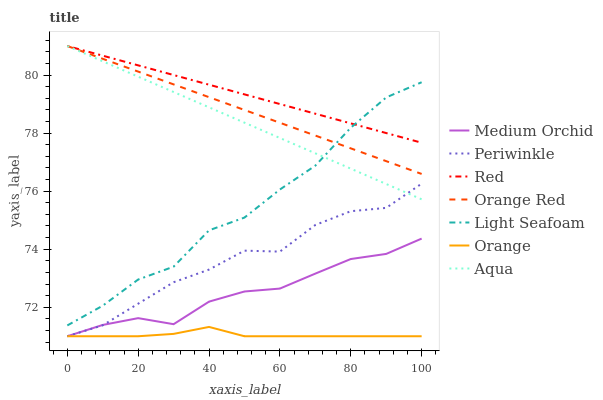Does Orange have the minimum area under the curve?
Answer yes or no. Yes. Does Red have the maximum area under the curve?
Answer yes or no. Yes. Does Aqua have the minimum area under the curve?
Answer yes or no. No. Does Aqua have the maximum area under the curve?
Answer yes or no. No. Is Aqua the smoothest?
Answer yes or no. Yes. Is Light Seafoam the roughest?
Answer yes or no. Yes. Is Periwinkle the smoothest?
Answer yes or no. No. Is Periwinkle the roughest?
Answer yes or no. No. Does Medium Orchid have the lowest value?
Answer yes or no. Yes. Does Aqua have the lowest value?
Answer yes or no. No. Does Red have the highest value?
Answer yes or no. Yes. Does Periwinkle have the highest value?
Answer yes or no. No. Is Orange less than Red?
Answer yes or no. Yes. Is Red greater than Orange?
Answer yes or no. Yes. Does Orange Red intersect Light Seafoam?
Answer yes or no. Yes. Is Orange Red less than Light Seafoam?
Answer yes or no. No. Is Orange Red greater than Light Seafoam?
Answer yes or no. No. Does Orange intersect Red?
Answer yes or no. No. 